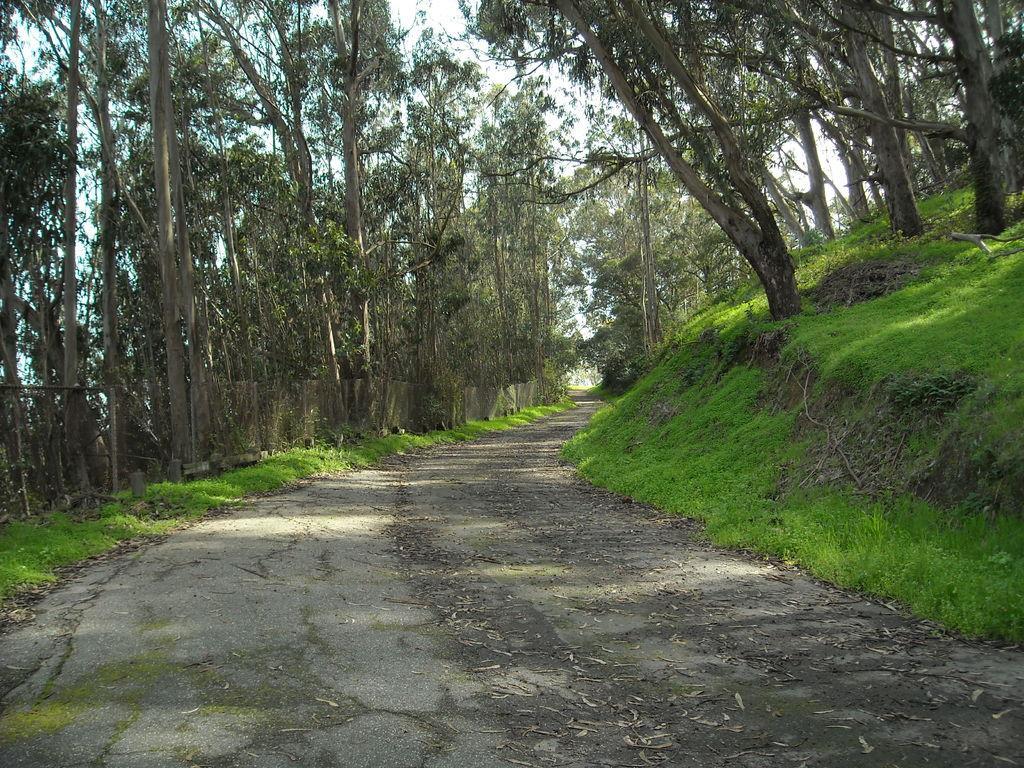Please provide a concise description of this image. In this image we can see some trees, grass, also we can see the sky. 